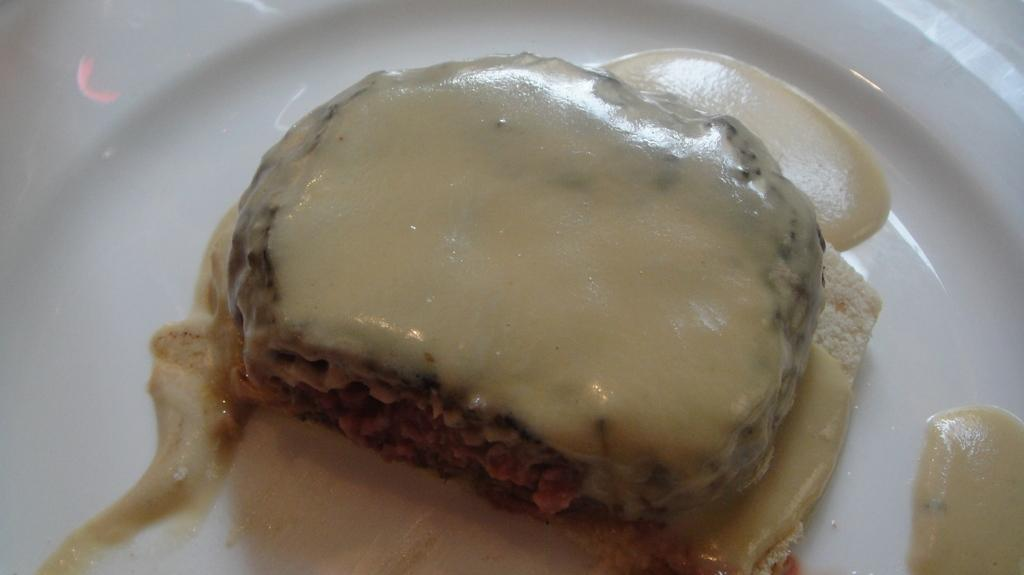What object is present on the plate in the image? There is a plate in the image. What color is the plate? The plate is white. What is on top of the plate? There is food on the plate. What colors can be seen in the food? The food has cream and brown colors. How many geese are visible in the image? There are no geese present in the image. What type of waste is being disposed of in the image? There is no waste being disposed of in the image. 